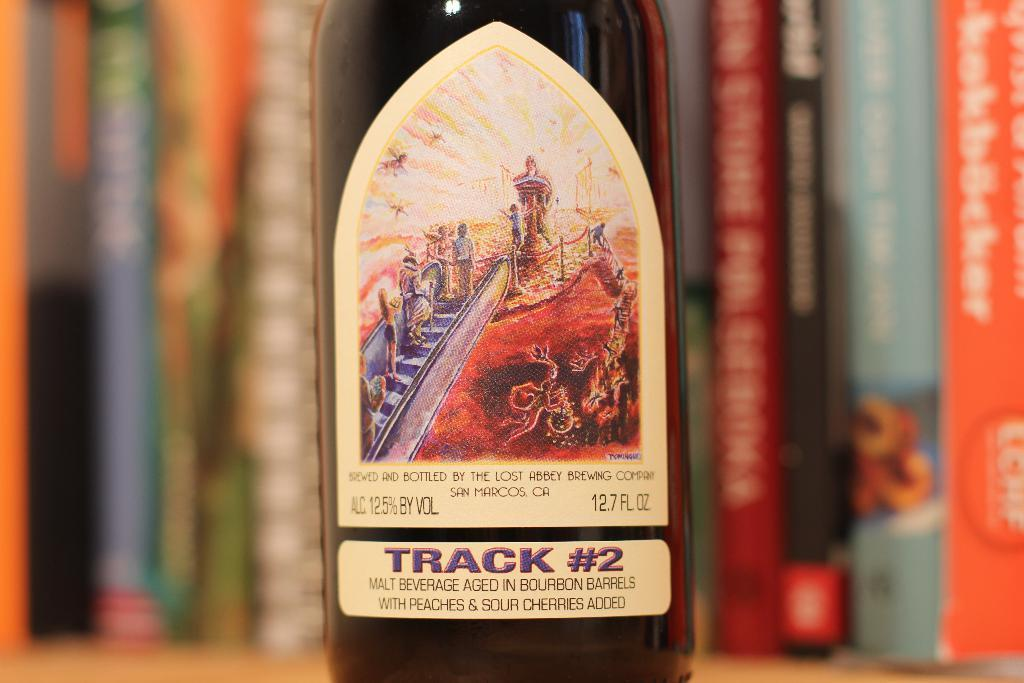<image>
Share a concise interpretation of the image provided. A closeup of a malt beverage bottle labeled track #2 